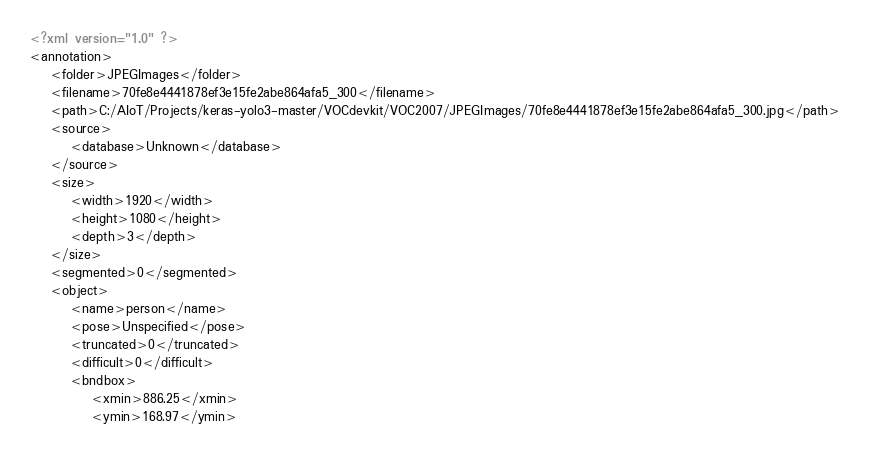<code> <loc_0><loc_0><loc_500><loc_500><_XML_><?xml version="1.0" ?>
<annotation>
	<folder>JPEGImages</folder>
	<filename>70fe8e4441878ef3e15fe2abe864afa5_300</filename>
	<path>C:/AIoT/Projects/keras-yolo3-master/VOCdevkit/VOC2007/JPEGImages/70fe8e4441878ef3e15fe2abe864afa5_300.jpg</path>
	<source>
		<database>Unknown</database>
	</source>
	<size>
		<width>1920</width>
		<height>1080</height>
		<depth>3</depth>
	</size>
	<segmented>0</segmented>
	<object>
		<name>person</name>
		<pose>Unspecified</pose>
		<truncated>0</truncated>
		<difficult>0</difficult>
		<bndbox>
			<xmin>886.25</xmin>
			<ymin>168.97</ymin></code> 